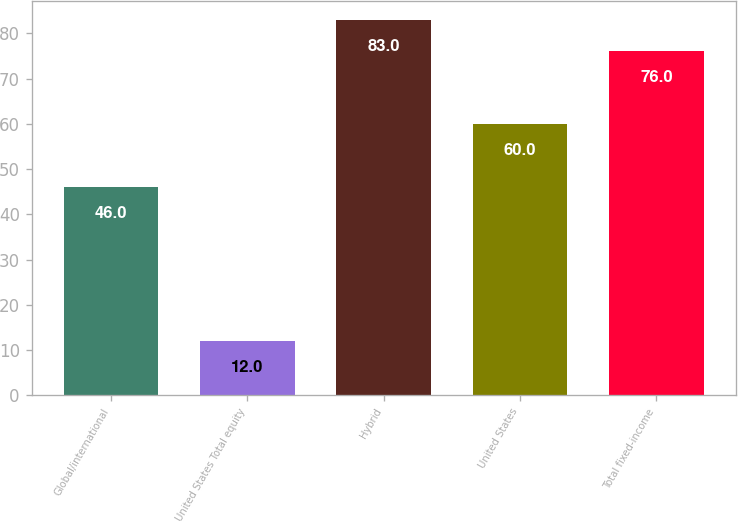Convert chart. <chart><loc_0><loc_0><loc_500><loc_500><bar_chart><fcel>Global/international<fcel>United States Total equity<fcel>Hybrid<fcel>United States<fcel>Total fixed-income<nl><fcel>46<fcel>12<fcel>83<fcel>60<fcel>76<nl></chart> 